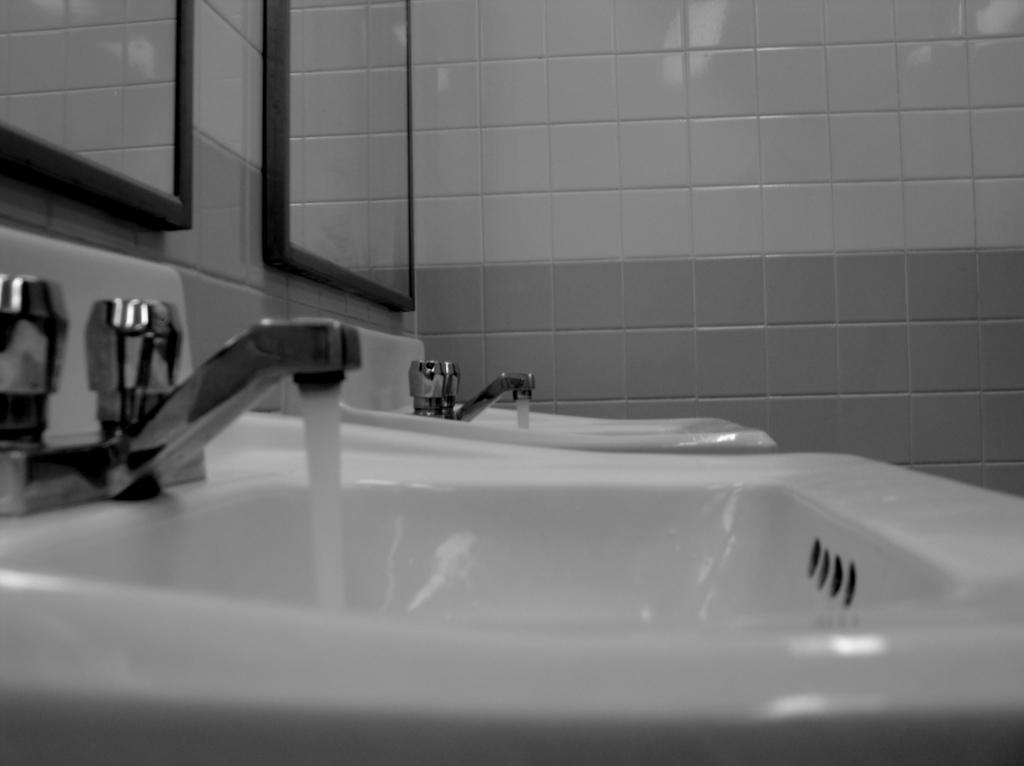How many hand wash sinks are visible in the image? There are two hand wash sinks in the image. What is the state of the taps on the sinks? The taps of the sinks are kept opened. What is happening with the water in the image? Water is flowing from the taps. What can be seen on the wall in the image? There are mirrors and tiles on the wall. How many baskets are hanging on the wall in the image? There are no baskets visible in the image; only mirrors and tiles can be seen on the wall. 